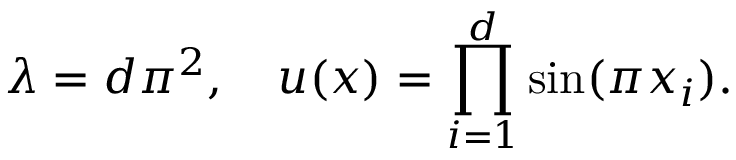Convert formula to latex. <formula><loc_0><loc_0><loc_500><loc_500>\lambda = d \pi ^ { 2 } , \quad u ( x ) = \prod _ { i = 1 } ^ { d } \sin ( \pi x _ { i } ) .</formula> 